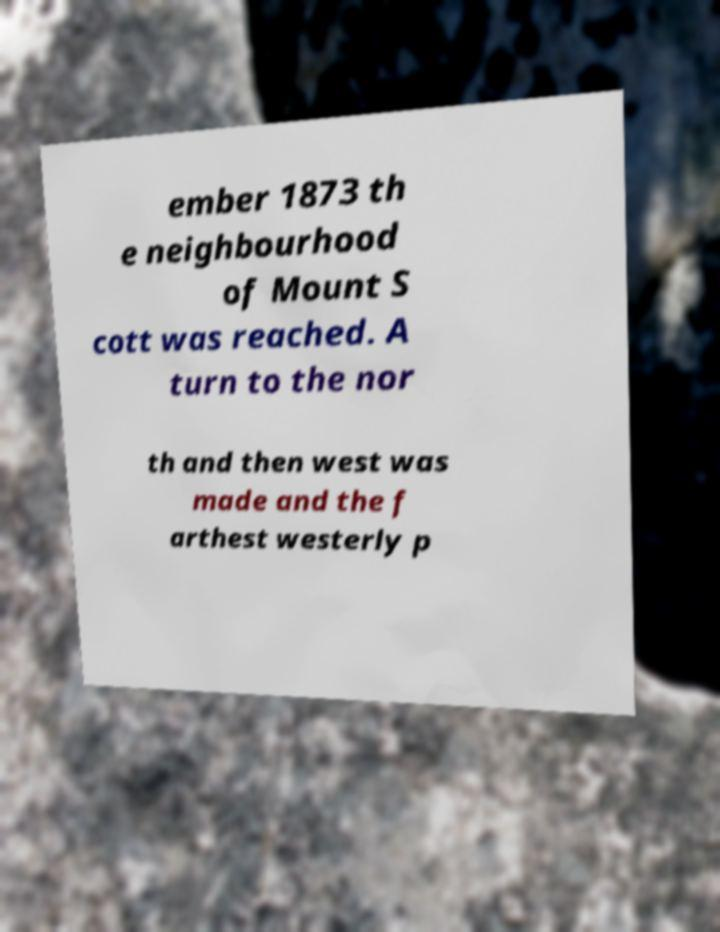Can you accurately transcribe the text from the provided image for me? ember 1873 th e neighbourhood of Mount S cott was reached. A turn to the nor th and then west was made and the f arthest westerly p 